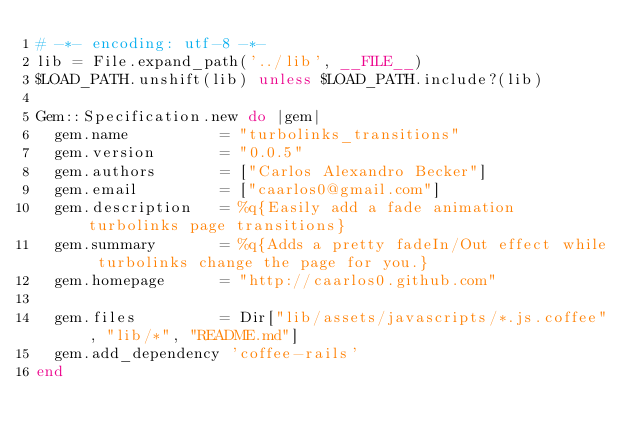Convert code to text. <code><loc_0><loc_0><loc_500><loc_500><_Ruby_># -*- encoding: utf-8 -*-
lib = File.expand_path('../lib', __FILE__)
$LOAD_PATH.unshift(lib) unless $LOAD_PATH.include?(lib)

Gem::Specification.new do |gem|
  gem.name          = "turbolinks_transitions"
  gem.version       = "0.0.5"
  gem.authors       = ["Carlos Alexandro Becker"]
  gem.email         = ["caarlos0@gmail.com"]
  gem.description   = %q{Easily add a fade animation turbolinks page transitions}
  gem.summary       = %q{Adds a pretty fadeIn/Out effect while turbolinks change the page for you.}
  gem.homepage      = "http://caarlos0.github.com"

  gem.files         = Dir["lib/assets/javascripts/*.js.coffee", "lib/*", "README.md"]
  gem.add_dependency 'coffee-rails'
end
</code> 